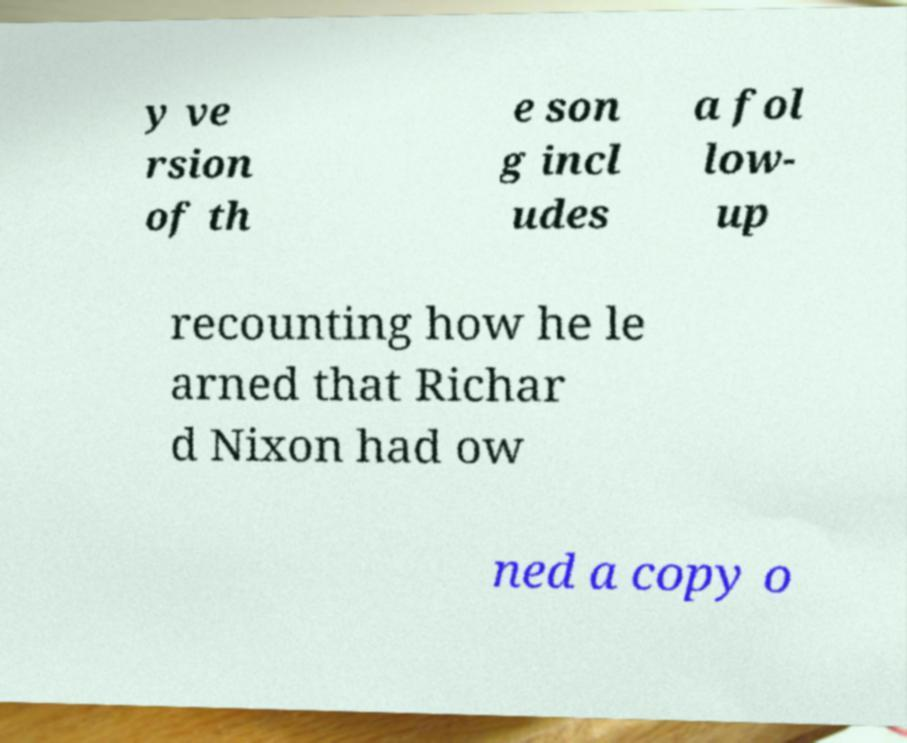There's text embedded in this image that I need extracted. Can you transcribe it verbatim? y ve rsion of th e son g incl udes a fol low- up recounting how he le arned that Richar d Nixon had ow ned a copy o 